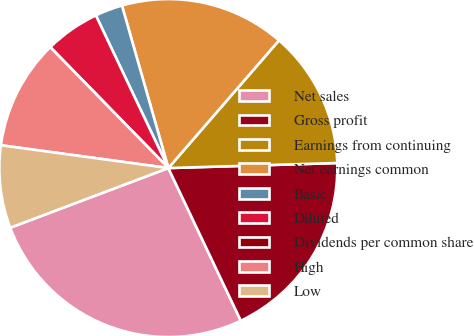<chart> <loc_0><loc_0><loc_500><loc_500><pie_chart><fcel>Net sales<fcel>Gross profit<fcel>Earnings from continuing<fcel>Net earnings common<fcel>Basic<fcel>Diluted<fcel>Dividends per common share<fcel>High<fcel>Low<nl><fcel>26.31%<fcel>18.42%<fcel>13.16%<fcel>15.79%<fcel>2.63%<fcel>5.26%<fcel>0.0%<fcel>10.53%<fcel>7.9%<nl></chart> 